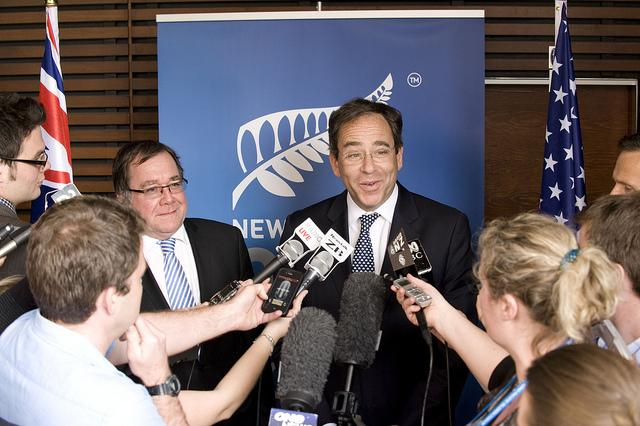Why are the people holding microphones? Please explain your reasoning. to interview. People are holding microphones to interview the man at the podium. 